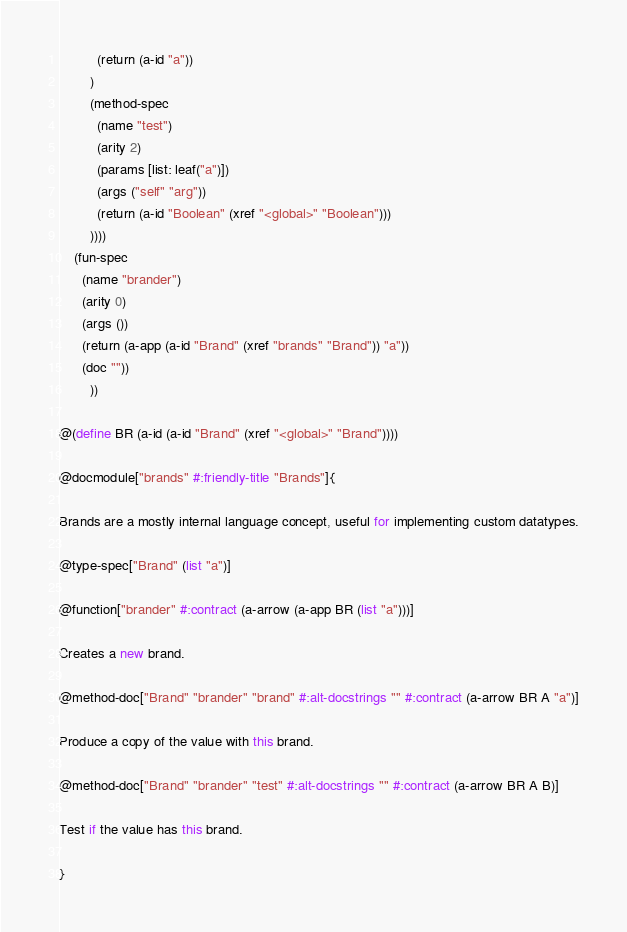<code> <loc_0><loc_0><loc_500><loc_500><_Racket_>          (return (a-id "a"))
        )
        (method-spec
          (name "test")
          (arity 2)
          (params [list: leaf("a")])
          (args ("self" "arg"))
          (return (a-id "Boolean" (xref "<global>" "Boolean")))
        ))))
    (fun-spec
      (name "brander")
      (arity 0)
      (args ())
      (return (a-app (a-id "Brand" (xref "brands" "Brand")) "a"))
      (doc ""))
        ))

@(define BR (a-id (a-id "Brand" (xref "<global>" "Brand"))))

@docmodule["brands" #:friendly-title "Brands"]{

Brands are a mostly internal language concept, useful for implementing custom datatypes.

@type-spec["Brand" (list "a")]

@function["brander" #:contract (a-arrow (a-app BR (list "a")))]

Creates a new brand.

@method-doc["Brand" "brander" "brand" #:alt-docstrings "" #:contract (a-arrow BR A "a")]

Produce a copy of the value with this brand.

@method-doc["Brand" "brander" "test" #:alt-docstrings "" #:contract (a-arrow BR A B)]

Test if the value has this brand.

}
</code> 